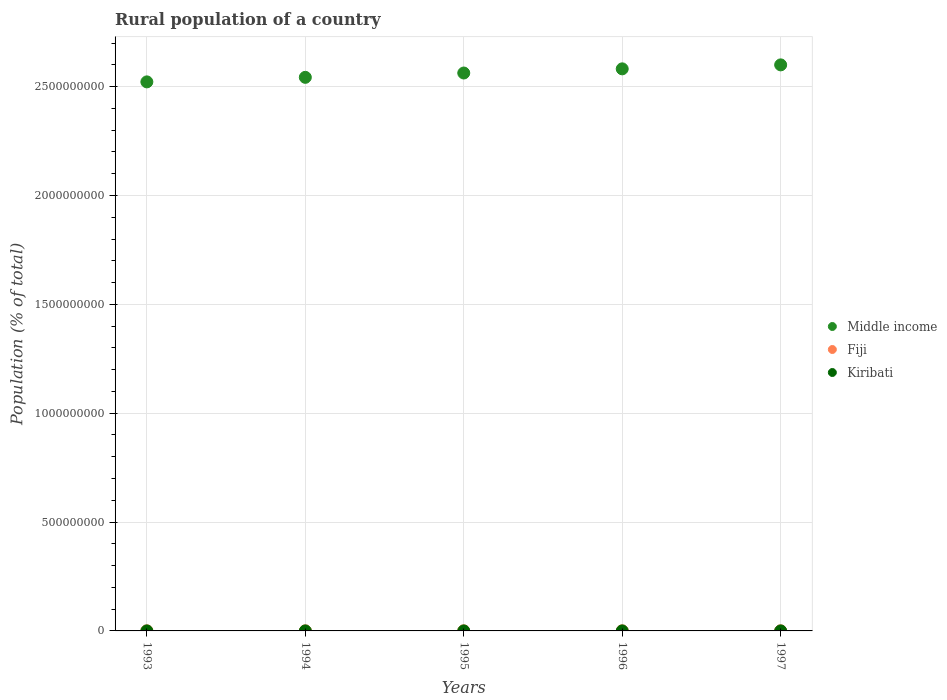Is the number of dotlines equal to the number of legend labels?
Offer a very short reply. Yes. What is the rural population in Middle income in 1997?
Keep it short and to the point. 2.60e+09. Across all years, what is the maximum rural population in Middle income?
Your answer should be compact. 2.60e+09. Across all years, what is the minimum rural population in Middle income?
Your answer should be very brief. 2.52e+09. In which year was the rural population in Middle income minimum?
Your answer should be very brief. 1993. What is the total rural population in Kiribati in the graph?
Give a very brief answer. 2.46e+05. What is the difference between the rural population in Middle income in 1995 and that in 1997?
Provide a succinct answer. -3.74e+07. What is the difference between the rural population in Kiribati in 1994 and the rural population in Middle income in 1995?
Ensure brevity in your answer.  -2.56e+09. What is the average rural population in Middle income per year?
Offer a very short reply. 2.56e+09. In the year 1997, what is the difference between the rural population in Middle income and rural population in Kiribati?
Your answer should be compact. 2.60e+09. What is the ratio of the rural population in Fiji in 1994 to that in 1995?
Offer a very short reply. 1. What is the difference between the highest and the second highest rural population in Middle income?
Offer a very short reply. 1.83e+07. What is the difference between the highest and the lowest rural population in Kiribati?
Ensure brevity in your answer.  843. In how many years, is the rural population in Fiji greater than the average rural population in Fiji taken over all years?
Your response must be concise. 3. Is the sum of the rural population in Fiji in 1996 and 1997 greater than the maximum rural population in Kiribati across all years?
Make the answer very short. Yes. Does the rural population in Kiribati monotonically increase over the years?
Ensure brevity in your answer.  No. Is the rural population in Kiribati strictly greater than the rural population in Middle income over the years?
Provide a short and direct response. No. How many dotlines are there?
Offer a very short reply. 3. What is the difference between two consecutive major ticks on the Y-axis?
Keep it short and to the point. 5.00e+08. Does the graph contain grids?
Make the answer very short. Yes. What is the title of the graph?
Keep it short and to the point. Rural population of a country. What is the label or title of the X-axis?
Keep it short and to the point. Years. What is the label or title of the Y-axis?
Offer a very short reply. Population (% of total). What is the Population (% of total) of Middle income in 1993?
Offer a very short reply. 2.52e+09. What is the Population (% of total) in Fiji in 1993?
Provide a succinct answer. 4.23e+05. What is the Population (% of total) of Kiribati in 1993?
Keep it short and to the point. 4.86e+04. What is the Population (% of total) of Middle income in 1994?
Provide a short and direct response. 2.54e+09. What is the Population (% of total) of Fiji in 1994?
Your answer should be compact. 4.23e+05. What is the Population (% of total) in Kiribati in 1994?
Offer a terse response. 4.90e+04. What is the Population (% of total) of Middle income in 1995?
Ensure brevity in your answer.  2.56e+09. What is the Population (% of total) in Fiji in 1995?
Offer a terse response. 4.23e+05. What is the Population (% of total) in Kiribati in 1995?
Provide a succinct answer. 4.94e+04. What is the Population (% of total) in Middle income in 1996?
Ensure brevity in your answer.  2.58e+09. What is the Population (% of total) of Fiji in 1996?
Offer a terse response. 4.21e+05. What is the Population (% of total) in Kiribati in 1996?
Ensure brevity in your answer.  4.94e+04. What is the Population (% of total) of Middle income in 1997?
Keep it short and to the point. 2.60e+09. What is the Population (% of total) of Fiji in 1997?
Keep it short and to the point. 4.22e+05. What is the Population (% of total) of Kiribati in 1997?
Make the answer very short. 4.91e+04. Across all years, what is the maximum Population (% of total) in Middle income?
Make the answer very short. 2.60e+09. Across all years, what is the maximum Population (% of total) in Fiji?
Provide a succinct answer. 4.23e+05. Across all years, what is the maximum Population (% of total) in Kiribati?
Provide a short and direct response. 4.94e+04. Across all years, what is the minimum Population (% of total) in Middle income?
Make the answer very short. 2.52e+09. Across all years, what is the minimum Population (% of total) in Fiji?
Provide a short and direct response. 4.21e+05. Across all years, what is the minimum Population (% of total) of Kiribati?
Your answer should be very brief. 4.86e+04. What is the total Population (% of total) in Middle income in the graph?
Give a very brief answer. 1.28e+1. What is the total Population (% of total) in Fiji in the graph?
Your answer should be compact. 2.11e+06. What is the total Population (% of total) in Kiribati in the graph?
Offer a very short reply. 2.46e+05. What is the difference between the Population (% of total) of Middle income in 1993 and that in 1994?
Your answer should be compact. -2.09e+07. What is the difference between the Population (% of total) of Kiribati in 1993 and that in 1994?
Your answer should be very brief. -393. What is the difference between the Population (% of total) in Middle income in 1993 and that in 1995?
Offer a terse response. -4.07e+07. What is the difference between the Population (% of total) in Fiji in 1993 and that in 1995?
Make the answer very short. 642. What is the difference between the Population (% of total) of Kiribati in 1993 and that in 1995?
Provide a short and direct response. -843. What is the difference between the Population (% of total) in Middle income in 1993 and that in 1996?
Offer a very short reply. -5.98e+07. What is the difference between the Population (% of total) in Fiji in 1993 and that in 1996?
Provide a succinct answer. 1913. What is the difference between the Population (% of total) in Kiribati in 1993 and that in 1996?
Provide a succinct answer. -823. What is the difference between the Population (% of total) of Middle income in 1993 and that in 1997?
Provide a short and direct response. -7.81e+07. What is the difference between the Population (% of total) of Fiji in 1993 and that in 1997?
Ensure brevity in your answer.  979. What is the difference between the Population (% of total) of Kiribati in 1993 and that in 1997?
Your answer should be compact. -531. What is the difference between the Population (% of total) of Middle income in 1994 and that in 1995?
Keep it short and to the point. -1.99e+07. What is the difference between the Population (% of total) of Fiji in 1994 and that in 1995?
Give a very brief answer. 637. What is the difference between the Population (% of total) of Kiribati in 1994 and that in 1995?
Your answer should be compact. -450. What is the difference between the Population (% of total) of Middle income in 1994 and that in 1996?
Give a very brief answer. -3.90e+07. What is the difference between the Population (% of total) of Fiji in 1994 and that in 1996?
Ensure brevity in your answer.  1908. What is the difference between the Population (% of total) of Kiribati in 1994 and that in 1996?
Make the answer very short. -430. What is the difference between the Population (% of total) in Middle income in 1994 and that in 1997?
Ensure brevity in your answer.  -5.73e+07. What is the difference between the Population (% of total) of Fiji in 1994 and that in 1997?
Keep it short and to the point. 974. What is the difference between the Population (% of total) of Kiribati in 1994 and that in 1997?
Give a very brief answer. -138. What is the difference between the Population (% of total) of Middle income in 1995 and that in 1996?
Make the answer very short. -1.91e+07. What is the difference between the Population (% of total) in Fiji in 1995 and that in 1996?
Keep it short and to the point. 1271. What is the difference between the Population (% of total) of Middle income in 1995 and that in 1997?
Offer a very short reply. -3.74e+07. What is the difference between the Population (% of total) in Fiji in 1995 and that in 1997?
Provide a succinct answer. 337. What is the difference between the Population (% of total) of Kiribati in 1995 and that in 1997?
Offer a very short reply. 312. What is the difference between the Population (% of total) of Middle income in 1996 and that in 1997?
Ensure brevity in your answer.  -1.83e+07. What is the difference between the Population (% of total) of Fiji in 1996 and that in 1997?
Offer a very short reply. -934. What is the difference between the Population (% of total) in Kiribati in 1996 and that in 1997?
Your answer should be very brief. 292. What is the difference between the Population (% of total) in Middle income in 1993 and the Population (% of total) in Fiji in 1994?
Provide a short and direct response. 2.52e+09. What is the difference between the Population (% of total) of Middle income in 1993 and the Population (% of total) of Kiribati in 1994?
Make the answer very short. 2.52e+09. What is the difference between the Population (% of total) of Fiji in 1993 and the Population (% of total) of Kiribati in 1994?
Ensure brevity in your answer.  3.74e+05. What is the difference between the Population (% of total) in Middle income in 1993 and the Population (% of total) in Fiji in 1995?
Provide a succinct answer. 2.52e+09. What is the difference between the Population (% of total) in Middle income in 1993 and the Population (% of total) in Kiribati in 1995?
Offer a terse response. 2.52e+09. What is the difference between the Population (% of total) in Fiji in 1993 and the Population (% of total) in Kiribati in 1995?
Ensure brevity in your answer.  3.74e+05. What is the difference between the Population (% of total) of Middle income in 1993 and the Population (% of total) of Fiji in 1996?
Your answer should be compact. 2.52e+09. What is the difference between the Population (% of total) in Middle income in 1993 and the Population (% of total) in Kiribati in 1996?
Make the answer very short. 2.52e+09. What is the difference between the Population (% of total) in Fiji in 1993 and the Population (% of total) in Kiribati in 1996?
Your response must be concise. 3.74e+05. What is the difference between the Population (% of total) in Middle income in 1993 and the Population (% of total) in Fiji in 1997?
Provide a short and direct response. 2.52e+09. What is the difference between the Population (% of total) of Middle income in 1993 and the Population (% of total) of Kiribati in 1997?
Your answer should be compact. 2.52e+09. What is the difference between the Population (% of total) in Fiji in 1993 and the Population (% of total) in Kiribati in 1997?
Give a very brief answer. 3.74e+05. What is the difference between the Population (% of total) in Middle income in 1994 and the Population (% of total) in Fiji in 1995?
Ensure brevity in your answer.  2.54e+09. What is the difference between the Population (% of total) of Middle income in 1994 and the Population (% of total) of Kiribati in 1995?
Give a very brief answer. 2.54e+09. What is the difference between the Population (% of total) of Fiji in 1994 and the Population (% of total) of Kiribati in 1995?
Provide a short and direct response. 3.74e+05. What is the difference between the Population (% of total) of Middle income in 1994 and the Population (% of total) of Fiji in 1996?
Provide a succinct answer. 2.54e+09. What is the difference between the Population (% of total) of Middle income in 1994 and the Population (% of total) of Kiribati in 1996?
Provide a succinct answer. 2.54e+09. What is the difference between the Population (% of total) in Fiji in 1994 and the Population (% of total) in Kiribati in 1996?
Offer a terse response. 3.74e+05. What is the difference between the Population (% of total) of Middle income in 1994 and the Population (% of total) of Fiji in 1997?
Provide a short and direct response. 2.54e+09. What is the difference between the Population (% of total) of Middle income in 1994 and the Population (% of total) of Kiribati in 1997?
Provide a short and direct response. 2.54e+09. What is the difference between the Population (% of total) of Fiji in 1994 and the Population (% of total) of Kiribati in 1997?
Keep it short and to the point. 3.74e+05. What is the difference between the Population (% of total) in Middle income in 1995 and the Population (% of total) in Fiji in 1996?
Provide a short and direct response. 2.56e+09. What is the difference between the Population (% of total) of Middle income in 1995 and the Population (% of total) of Kiribati in 1996?
Provide a succinct answer. 2.56e+09. What is the difference between the Population (% of total) of Fiji in 1995 and the Population (% of total) of Kiribati in 1996?
Offer a very short reply. 3.73e+05. What is the difference between the Population (% of total) in Middle income in 1995 and the Population (% of total) in Fiji in 1997?
Give a very brief answer. 2.56e+09. What is the difference between the Population (% of total) of Middle income in 1995 and the Population (% of total) of Kiribati in 1997?
Your answer should be very brief. 2.56e+09. What is the difference between the Population (% of total) in Fiji in 1995 and the Population (% of total) in Kiribati in 1997?
Keep it short and to the point. 3.74e+05. What is the difference between the Population (% of total) in Middle income in 1996 and the Population (% of total) in Fiji in 1997?
Your answer should be compact. 2.58e+09. What is the difference between the Population (% of total) in Middle income in 1996 and the Population (% of total) in Kiribati in 1997?
Give a very brief answer. 2.58e+09. What is the difference between the Population (% of total) in Fiji in 1996 and the Population (% of total) in Kiribati in 1997?
Offer a very short reply. 3.72e+05. What is the average Population (% of total) in Middle income per year?
Offer a terse response. 2.56e+09. What is the average Population (% of total) of Fiji per year?
Provide a succinct answer. 4.23e+05. What is the average Population (% of total) in Kiribati per year?
Your answer should be compact. 4.91e+04. In the year 1993, what is the difference between the Population (% of total) of Middle income and Population (% of total) of Fiji?
Make the answer very short. 2.52e+09. In the year 1993, what is the difference between the Population (% of total) of Middle income and Population (% of total) of Kiribati?
Provide a succinct answer. 2.52e+09. In the year 1993, what is the difference between the Population (% of total) of Fiji and Population (% of total) of Kiribati?
Keep it short and to the point. 3.75e+05. In the year 1994, what is the difference between the Population (% of total) of Middle income and Population (% of total) of Fiji?
Give a very brief answer. 2.54e+09. In the year 1994, what is the difference between the Population (% of total) of Middle income and Population (% of total) of Kiribati?
Your answer should be very brief. 2.54e+09. In the year 1994, what is the difference between the Population (% of total) in Fiji and Population (% of total) in Kiribati?
Ensure brevity in your answer.  3.74e+05. In the year 1995, what is the difference between the Population (% of total) of Middle income and Population (% of total) of Fiji?
Offer a very short reply. 2.56e+09. In the year 1995, what is the difference between the Population (% of total) of Middle income and Population (% of total) of Kiribati?
Provide a short and direct response. 2.56e+09. In the year 1995, what is the difference between the Population (% of total) of Fiji and Population (% of total) of Kiribati?
Give a very brief answer. 3.73e+05. In the year 1996, what is the difference between the Population (% of total) of Middle income and Population (% of total) of Fiji?
Ensure brevity in your answer.  2.58e+09. In the year 1996, what is the difference between the Population (% of total) in Middle income and Population (% of total) in Kiribati?
Keep it short and to the point. 2.58e+09. In the year 1996, what is the difference between the Population (% of total) of Fiji and Population (% of total) of Kiribati?
Give a very brief answer. 3.72e+05. In the year 1997, what is the difference between the Population (% of total) in Middle income and Population (% of total) in Fiji?
Ensure brevity in your answer.  2.60e+09. In the year 1997, what is the difference between the Population (% of total) of Middle income and Population (% of total) of Kiribati?
Offer a terse response. 2.60e+09. In the year 1997, what is the difference between the Population (% of total) in Fiji and Population (% of total) in Kiribati?
Your answer should be very brief. 3.73e+05. What is the ratio of the Population (% of total) of Middle income in 1993 to that in 1995?
Provide a succinct answer. 0.98. What is the ratio of the Population (% of total) of Fiji in 1993 to that in 1995?
Keep it short and to the point. 1. What is the ratio of the Population (% of total) in Kiribati in 1993 to that in 1995?
Offer a terse response. 0.98. What is the ratio of the Population (% of total) in Middle income in 1993 to that in 1996?
Your answer should be compact. 0.98. What is the ratio of the Population (% of total) of Fiji in 1993 to that in 1996?
Your answer should be compact. 1. What is the ratio of the Population (% of total) of Kiribati in 1993 to that in 1996?
Offer a terse response. 0.98. What is the ratio of the Population (% of total) of Middle income in 1993 to that in 1997?
Your answer should be very brief. 0.97. What is the ratio of the Population (% of total) of Fiji in 1993 to that in 1997?
Make the answer very short. 1. What is the ratio of the Population (% of total) in Kiribati in 1993 to that in 1997?
Your answer should be compact. 0.99. What is the ratio of the Population (% of total) of Middle income in 1994 to that in 1995?
Make the answer very short. 0.99. What is the ratio of the Population (% of total) in Kiribati in 1994 to that in 1995?
Your answer should be compact. 0.99. What is the ratio of the Population (% of total) of Middle income in 1994 to that in 1996?
Give a very brief answer. 0.98. What is the ratio of the Population (% of total) in Kiribati in 1994 to that in 1996?
Provide a succinct answer. 0.99. What is the ratio of the Population (% of total) in Kiribati in 1994 to that in 1997?
Your answer should be compact. 1. What is the ratio of the Population (% of total) of Kiribati in 1995 to that in 1996?
Keep it short and to the point. 1. What is the ratio of the Population (% of total) of Middle income in 1995 to that in 1997?
Ensure brevity in your answer.  0.99. What is the ratio of the Population (% of total) of Kiribati in 1995 to that in 1997?
Ensure brevity in your answer.  1.01. What is the ratio of the Population (% of total) in Kiribati in 1996 to that in 1997?
Offer a very short reply. 1.01. What is the difference between the highest and the second highest Population (% of total) of Middle income?
Provide a short and direct response. 1.83e+07. What is the difference between the highest and the second highest Population (% of total) in Kiribati?
Your answer should be compact. 20. What is the difference between the highest and the lowest Population (% of total) of Middle income?
Provide a short and direct response. 7.81e+07. What is the difference between the highest and the lowest Population (% of total) of Fiji?
Ensure brevity in your answer.  1913. What is the difference between the highest and the lowest Population (% of total) of Kiribati?
Offer a terse response. 843. 